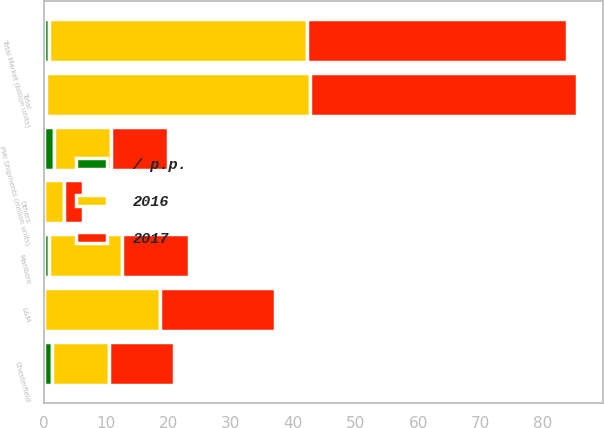Convert chart. <chart><loc_0><loc_0><loc_500><loc_500><stacked_bar_chart><ecel><fcel>Total Market (billion units)<fcel>PMI Shipments (million units)<fcel>Marlboro<fcel>L&M<fcel>Chesterfield<fcel>Others<fcel>Total<nl><fcel>2017<fcel>41.7<fcel>9.1<fcel>10.7<fcel>18.4<fcel>10.4<fcel>3<fcel>42.7<nl><fcel>2016<fcel>41.3<fcel>9.1<fcel>11.6<fcel>18.5<fcel>9.1<fcel>3.1<fcel>42.3<nl><fcel>/ p.p.<fcel>0.9<fcel>1.7<fcel>0.9<fcel>0.1<fcel>1.3<fcel>0.1<fcel>0.4<nl></chart> 